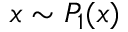Convert formula to latex. <formula><loc_0><loc_0><loc_500><loc_500>x \sim P _ { 1 } ( x )</formula> 